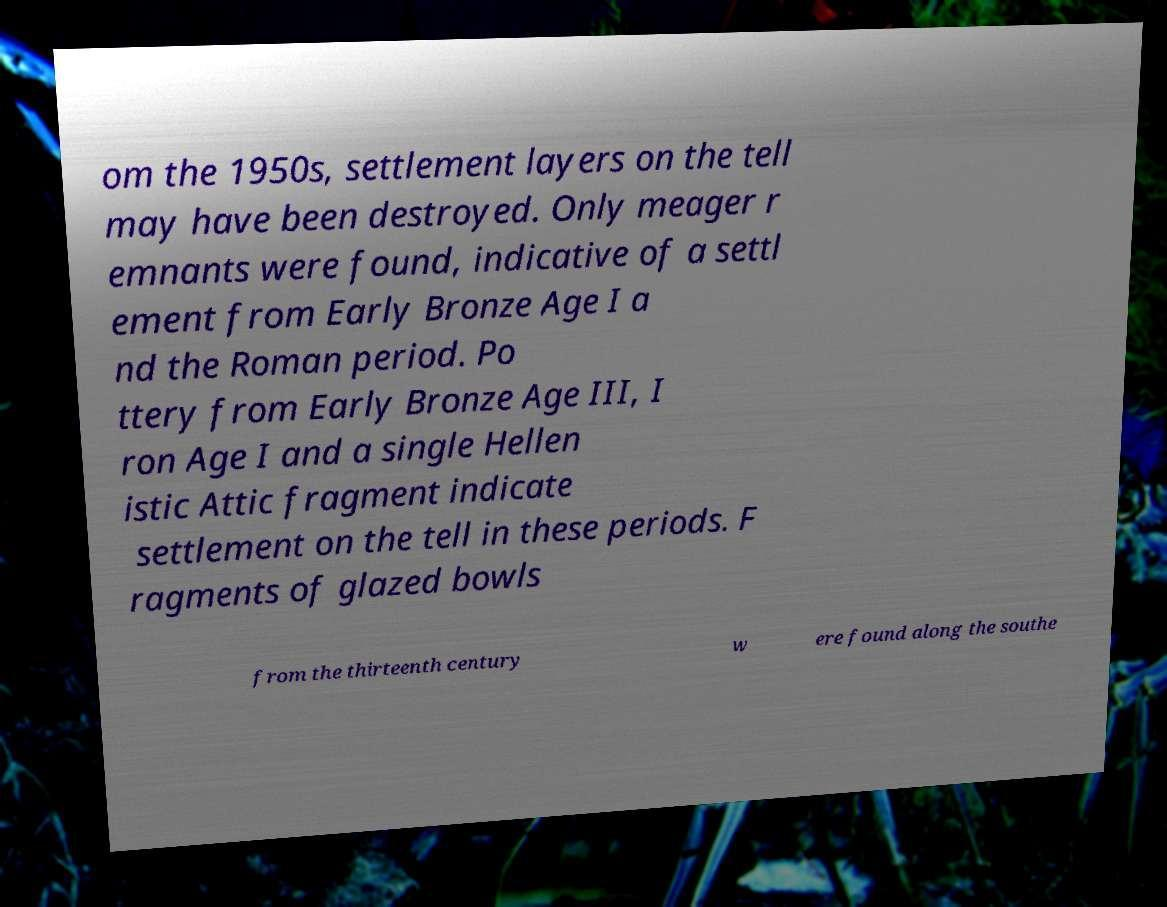There's text embedded in this image that I need extracted. Can you transcribe it verbatim? om the 1950s, settlement layers on the tell may have been destroyed. Only meager r emnants were found, indicative of a settl ement from Early Bronze Age I a nd the Roman period. Po ttery from Early Bronze Age III, I ron Age I and a single Hellen istic Attic fragment indicate settlement on the tell in these periods. F ragments of glazed bowls from the thirteenth century w ere found along the southe 